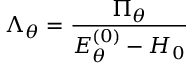Convert formula to latex. <formula><loc_0><loc_0><loc_500><loc_500>\Lambda _ { \theta } = \frac { \Pi _ { \theta } } { E _ { \theta } ^ { ( 0 ) } - H _ { 0 } }</formula> 